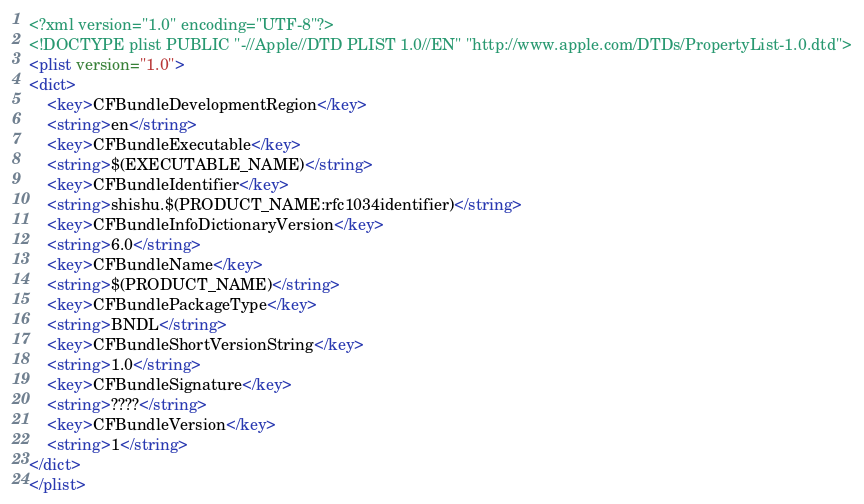Convert code to text. <code><loc_0><loc_0><loc_500><loc_500><_XML_><?xml version="1.0" encoding="UTF-8"?>
<!DOCTYPE plist PUBLIC "-//Apple//DTD PLIST 1.0//EN" "http://www.apple.com/DTDs/PropertyList-1.0.dtd">
<plist version="1.0">
<dict>
	<key>CFBundleDevelopmentRegion</key>
	<string>en</string>
	<key>CFBundleExecutable</key>
	<string>$(EXECUTABLE_NAME)</string>
	<key>CFBundleIdentifier</key>
	<string>shishu.$(PRODUCT_NAME:rfc1034identifier)</string>
	<key>CFBundleInfoDictionaryVersion</key>
	<string>6.0</string>
	<key>CFBundleName</key>
	<string>$(PRODUCT_NAME)</string>
	<key>CFBundlePackageType</key>
	<string>BNDL</string>
	<key>CFBundleShortVersionString</key>
	<string>1.0</string>
	<key>CFBundleSignature</key>
	<string>????</string>
	<key>CFBundleVersion</key>
	<string>1</string>
</dict>
</plist>
</code> 